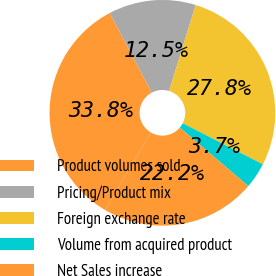Convert chart to OTSL. <chart><loc_0><loc_0><loc_500><loc_500><pie_chart><fcel>Product volumes sold<fcel>Pricing/Product mix<fcel>Foreign exchange rate<fcel>Volume from acquired product<fcel>Net Sales increase<nl><fcel>33.8%<fcel>12.5%<fcel>27.78%<fcel>3.7%<fcel>22.22%<nl></chart> 